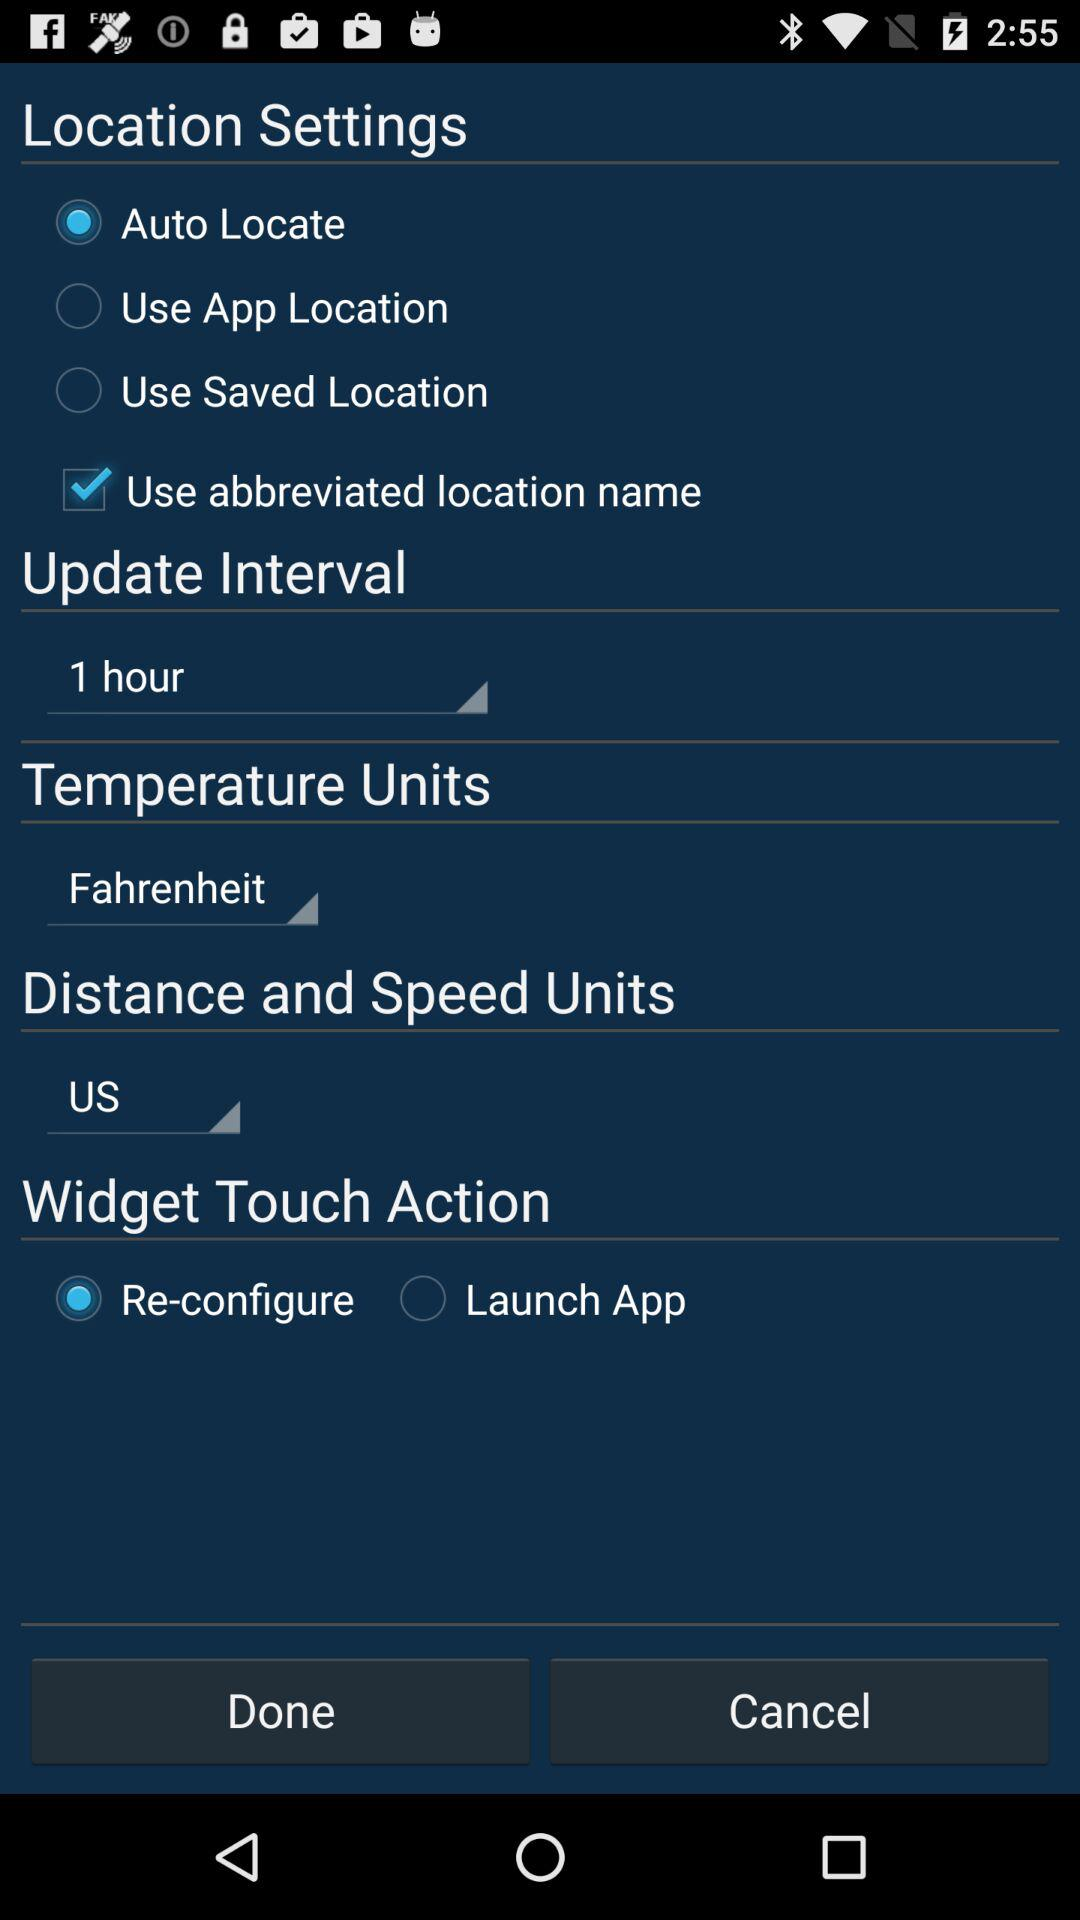What is the status of the "Use abbreviated location name"? The status is "on". 